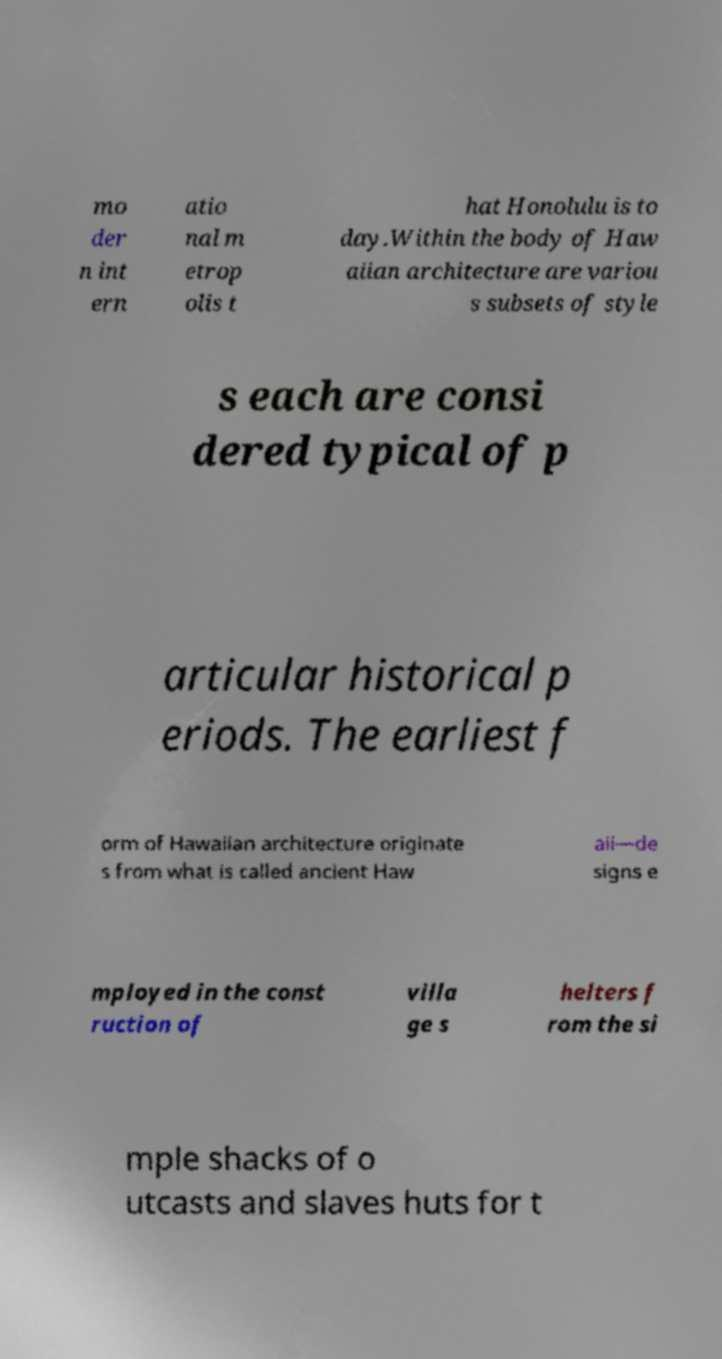Can you read and provide the text displayed in the image?This photo seems to have some interesting text. Can you extract and type it out for me? mo der n int ern atio nal m etrop olis t hat Honolulu is to day.Within the body of Haw aiian architecture are variou s subsets of style s each are consi dered typical of p articular historical p eriods. The earliest f orm of Hawaiian architecture originate s from what is called ancient Haw aii—de signs e mployed in the const ruction of villa ge s helters f rom the si mple shacks of o utcasts and slaves huts for t 